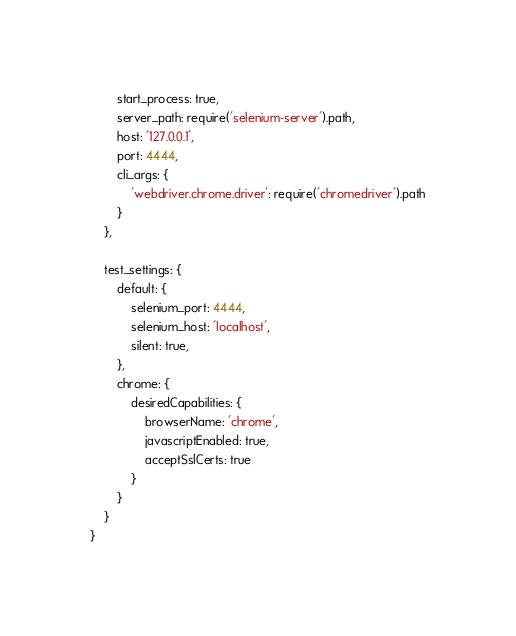Convert code to text. <code><loc_0><loc_0><loc_500><loc_500><_JavaScript_>        start_process: true,
        server_path: require('selenium-server').path,
        host: '127.0.0.1',
        port: 4444,
        cli_args: {
            'webdriver.chrome.driver': require('chromedriver').path
        }
    },

    test_settings: {
        default: {
            selenium_port: 4444,
            selenium_host: 'localhost',
            silent: true,
        },
        chrome: {
            desiredCapabilities: {
                browserName: 'chrome',
                javascriptEnabled: true,
                acceptSslCerts: true
            }
        }
    }
}
</code> 